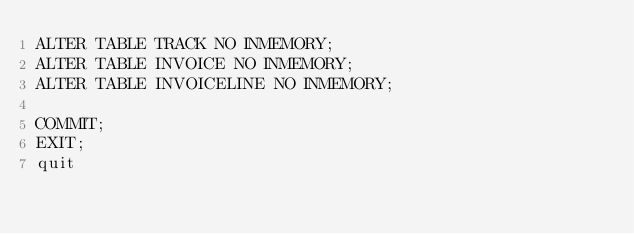Convert code to text. <code><loc_0><loc_0><loc_500><loc_500><_SQL_>ALTER TABLE TRACK NO INMEMORY;
ALTER TABLE INVOICE NO INMEMORY;
ALTER TABLE INVOICELINE NO INMEMORY;

COMMIT;
EXIT;
quit</code> 